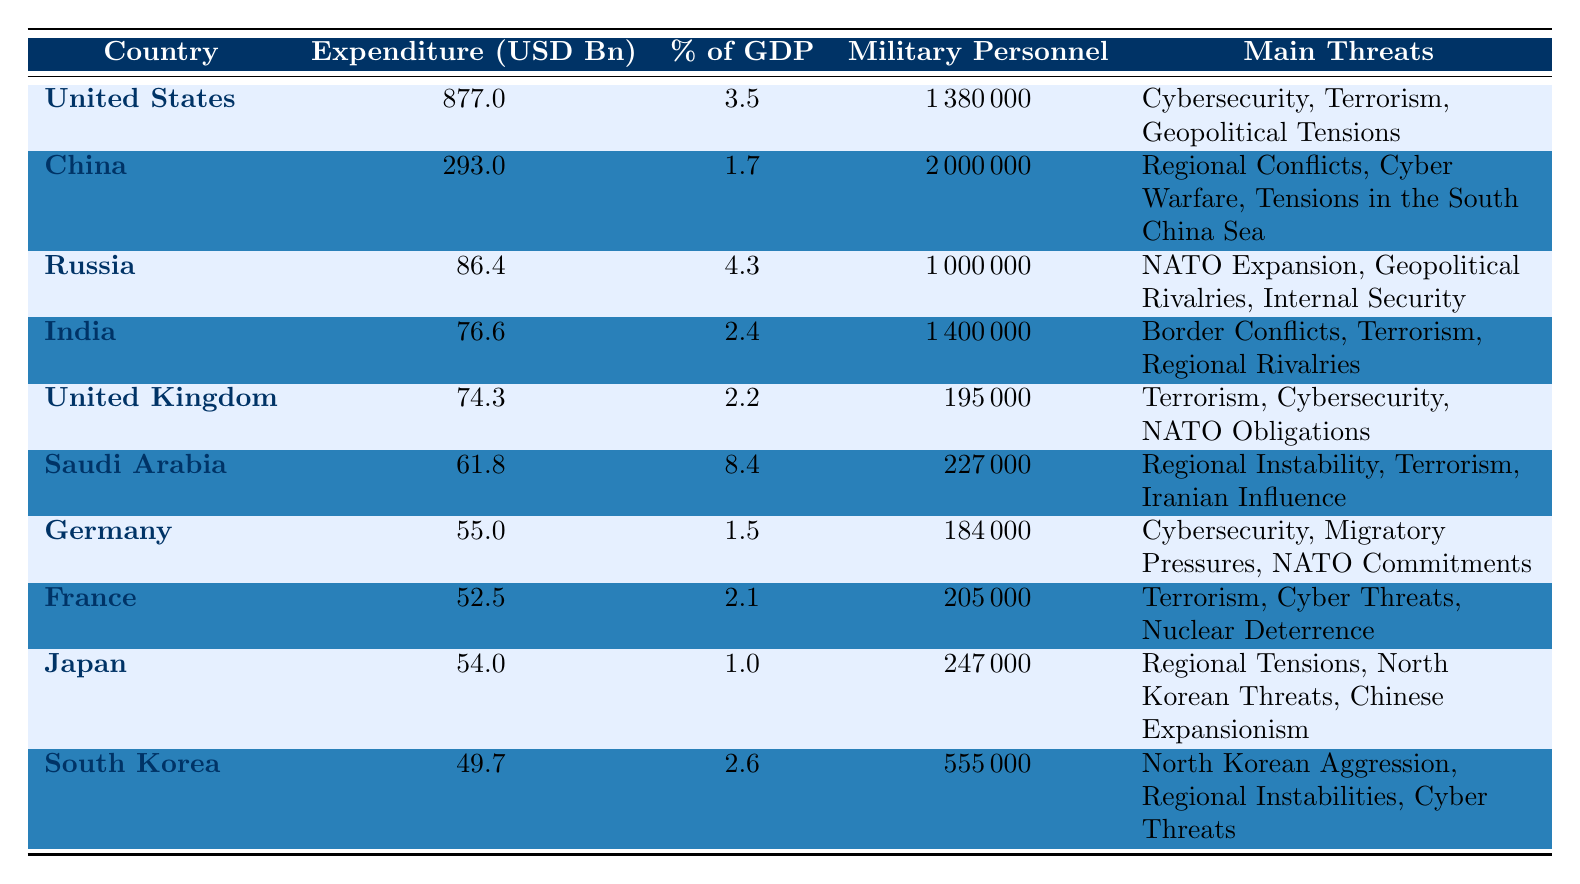What country has the highest military expenditure in 2022? By looking at the "Expenditure (USD Bn)" column, the United States has the highest figure of 877.0 billion USD.
Answer: United States Which country has a military expenditure that makes up 4.3% of its GDP? Referring to the "Percentage of GDP" column, Russia is listed with an expenditure that equals 4.3% of its GDP.
Answer: Russia What is the total military expenditure of the top three countries in the table? The top three countries are the United States (877.0), China (293.0), and Russia (86.4). Adding these values: 877.0 + 293.0 + 86.4 = 1256.4 billion USD.
Answer: 1256.4 Which country has the largest number of military personnel? China has the highest count of military personnel at 2,000,000, according to the "Military Personnel" column.
Answer: China Is the United Kingdom’s military expenditure a higher percentage of GDP than Germany's? The United Kingdom's military expenditure is 2.2% of GDP, while Germany's is 1.5%. Thus, the UK’s is higher.
Answer: Yes What is the average military expenditure among the countries listed in the table? The total military expenditure sums up to 1,509.4 billion USD (877.0 + 293.0 + 86.4 + 76.6 + 74.3 + 61.8 + 55.0 + 52.5 + 54.0 + 49.7). Since there are 10 countries, the average is 1,509.4/10 = 150.94 billion USD.
Answer: 150.94 What percentage of the GDP does Saudi Arabia spend on military compared to India? Saudi Arabia spends 8.4% of its GDP while India spends 2.4%. Saudi Arabia’s percentage is higher than India’s.
Answer: Yes Which country has the main threat of "North Korean Threats"? The "Main Threats" column indicates Japan faces the threat of "North Korean Threats".
Answer: Japan How many countries have military expenditures above 50 billion USD? Referring to the expenditure values, the countries are the United States, China, Russia, India, United Kingdom, and Saudi Arabia, totaling 6 countries above 50 billion USD.
Answer: 6 Which two countries have terrorism listed as a main threat? By examining the "Main Threats" column, both the United States and India have "Terrorism" listed.
Answer: United States and India If we compare military expenditures, how much more does the United States spend compared to Japan? The United States spends 877.0 billion USD while Japan spends 54.0 billion USD. The difference is 877.0 - 54.0 = 823.0 billion USD.
Answer: 823.0 